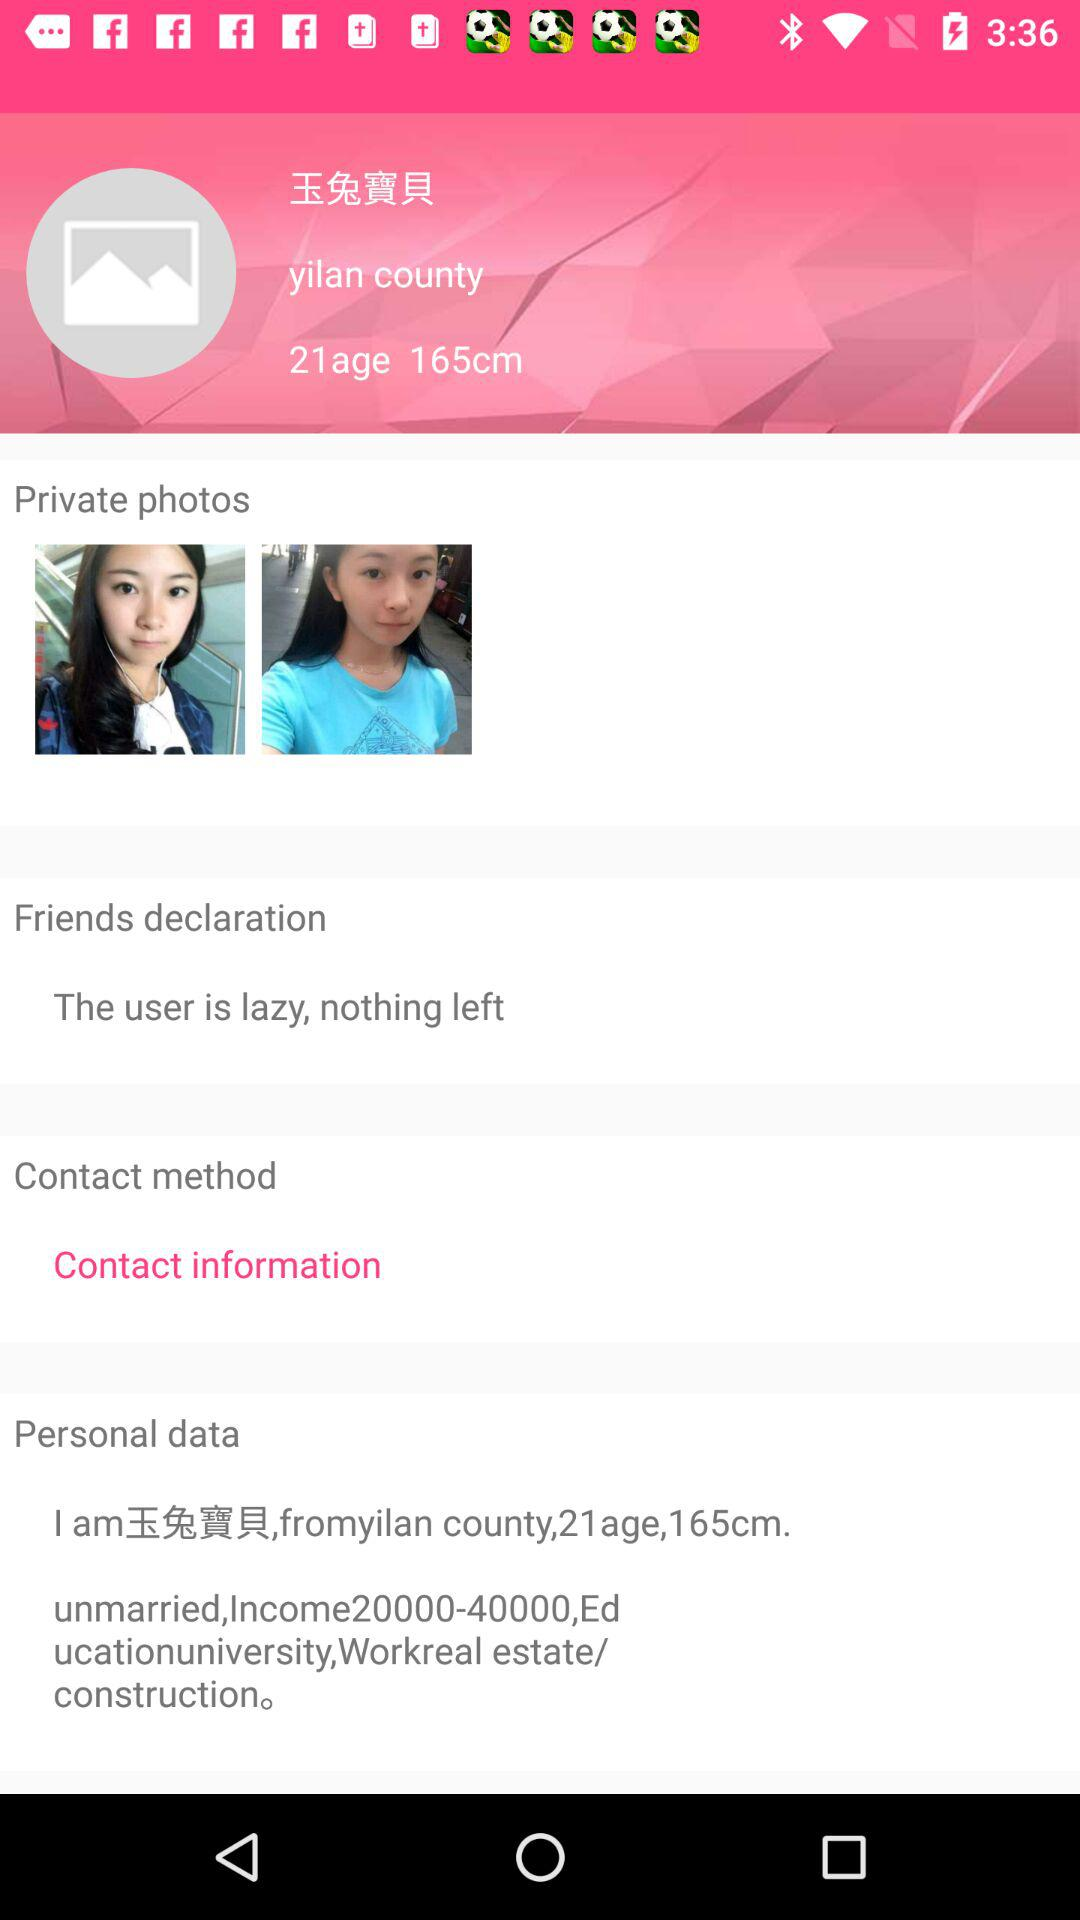What is the age? The age is 21 years old. 